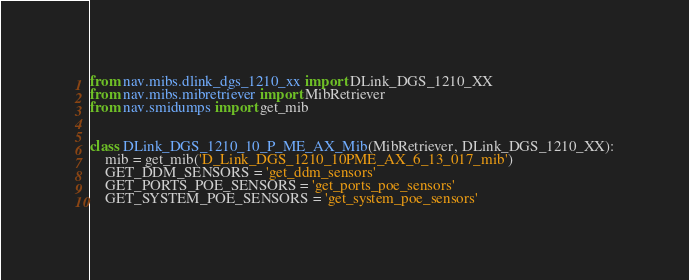<code> <loc_0><loc_0><loc_500><loc_500><_Python_>from nav.mibs.dlink_dgs_1210_xx import DLink_DGS_1210_XX
from nav.mibs.mibretriever import MibRetriever
from nav.smidumps import get_mib


class DLink_DGS_1210_10_P_ME_AX_Mib(MibRetriever, DLink_DGS_1210_XX):
    mib = get_mib('D_Link_DGS_1210_10PME_AX_6_13_017_mib')
    GET_DDM_SENSORS = 'get_ddm_sensors'
    GET_PORTS_POE_SENSORS = 'get_ports_poe_sensors'
    GET_SYSTEM_POE_SENSORS = 'get_system_poe_sensors'
</code> 